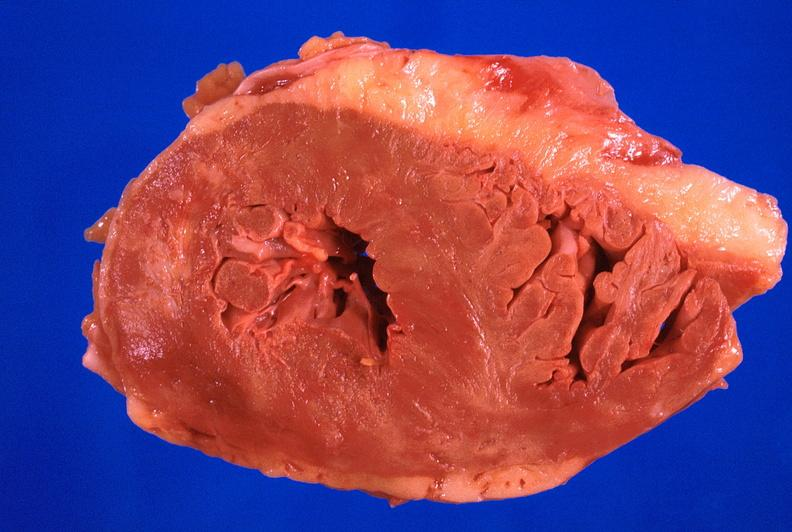does this image show heart, hypertrophy, chronic rheumatic heart disease with prosthetic mitral valve?
Answer the question using a single word or phrase. Yes 